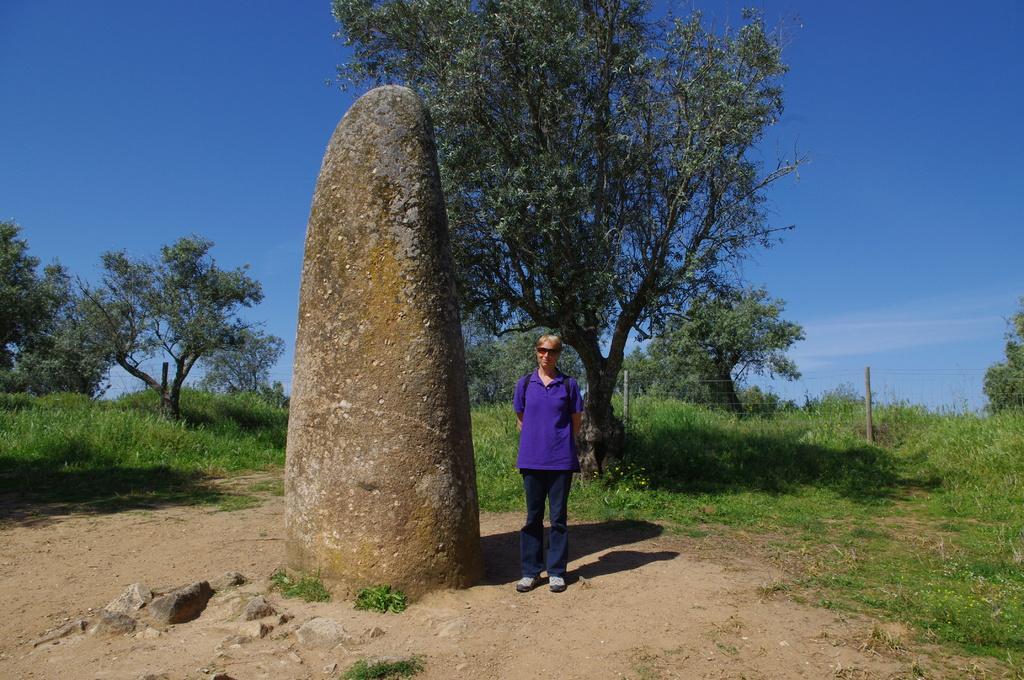How would you summarize this image in a sentence or two? In this is picture I can see there is a woman standing she is wearing a purple shirt and there is a rock beside her. There are trees and the sky is clear. 